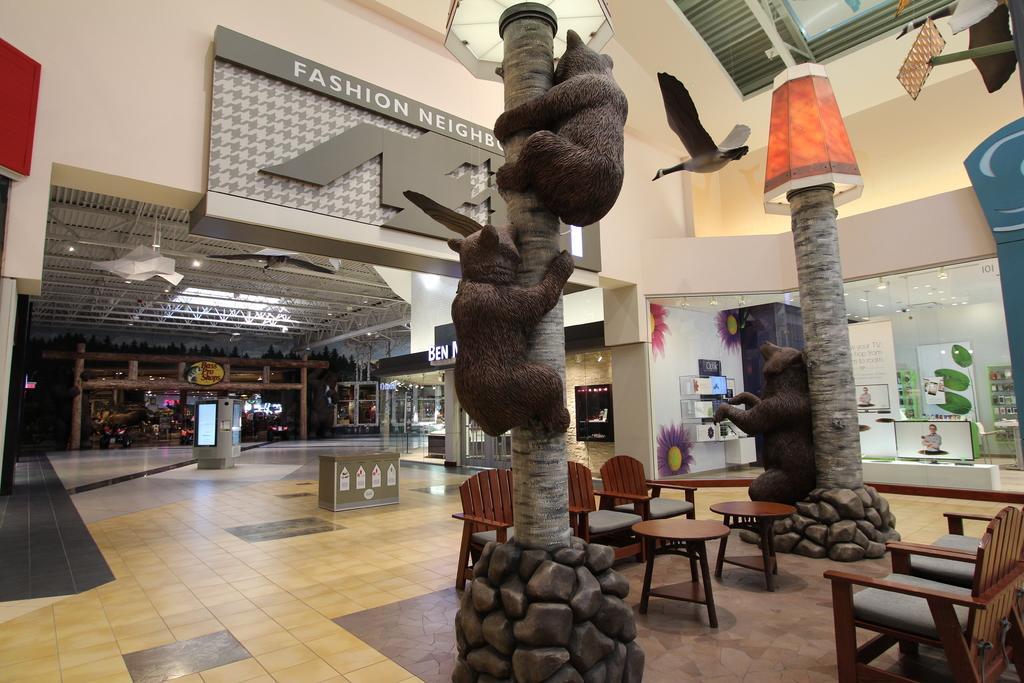Describe this image in one or two sentences. This picture is of inside which seems to be a mall. On the right we can see the chairs and tables. In the center we can see a sculpture of two animals and a tree and a sculpture of a bird. In the background we can see a wall and a shop. On the right we can see a television and some boxes. 